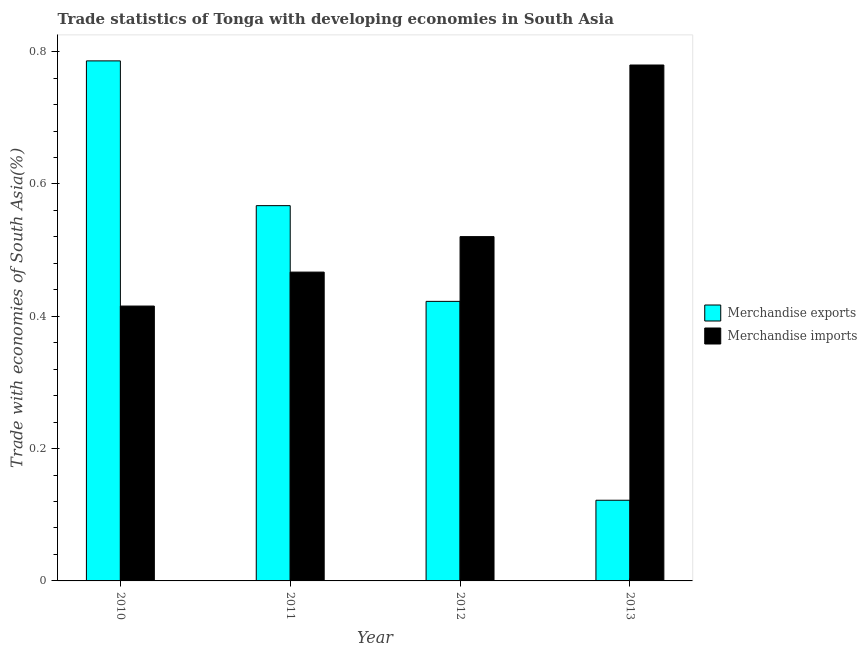How many different coloured bars are there?
Your answer should be compact. 2. Are the number of bars per tick equal to the number of legend labels?
Provide a short and direct response. Yes. How many bars are there on the 1st tick from the left?
Ensure brevity in your answer.  2. What is the label of the 2nd group of bars from the left?
Offer a very short reply. 2011. What is the merchandise imports in 2012?
Your answer should be compact. 0.52. Across all years, what is the maximum merchandise exports?
Your answer should be compact. 0.79. Across all years, what is the minimum merchandise exports?
Provide a succinct answer. 0.12. In which year was the merchandise exports minimum?
Make the answer very short. 2013. What is the total merchandise exports in the graph?
Make the answer very short. 1.9. What is the difference between the merchandise imports in 2011 and that in 2012?
Give a very brief answer. -0.05. What is the difference between the merchandise exports in 2011 and the merchandise imports in 2010?
Provide a short and direct response. -0.22. What is the average merchandise imports per year?
Your answer should be compact. 0.55. What is the ratio of the merchandise imports in 2010 to that in 2013?
Offer a very short reply. 0.53. Is the merchandise exports in 2012 less than that in 2013?
Give a very brief answer. No. Is the difference between the merchandise exports in 2011 and 2012 greater than the difference between the merchandise imports in 2011 and 2012?
Provide a short and direct response. No. What is the difference between the highest and the second highest merchandise imports?
Make the answer very short. 0.26. What is the difference between the highest and the lowest merchandise imports?
Give a very brief answer. 0.36. In how many years, is the merchandise exports greater than the average merchandise exports taken over all years?
Provide a succinct answer. 2. Is the sum of the merchandise exports in 2010 and 2012 greater than the maximum merchandise imports across all years?
Give a very brief answer. Yes. What does the 1st bar from the left in 2013 represents?
Keep it short and to the point. Merchandise exports. What does the 2nd bar from the right in 2012 represents?
Make the answer very short. Merchandise exports. How many years are there in the graph?
Your response must be concise. 4. What is the difference between two consecutive major ticks on the Y-axis?
Make the answer very short. 0.2. How are the legend labels stacked?
Your answer should be very brief. Vertical. What is the title of the graph?
Ensure brevity in your answer.  Trade statistics of Tonga with developing economies in South Asia. Does "International Visitors" appear as one of the legend labels in the graph?
Offer a terse response. No. What is the label or title of the Y-axis?
Provide a short and direct response. Trade with economies of South Asia(%). What is the Trade with economies of South Asia(%) of Merchandise exports in 2010?
Provide a short and direct response. 0.79. What is the Trade with economies of South Asia(%) in Merchandise imports in 2010?
Provide a short and direct response. 0.42. What is the Trade with economies of South Asia(%) of Merchandise exports in 2011?
Offer a very short reply. 0.57. What is the Trade with economies of South Asia(%) in Merchandise imports in 2011?
Your answer should be very brief. 0.47. What is the Trade with economies of South Asia(%) of Merchandise exports in 2012?
Provide a succinct answer. 0.42. What is the Trade with economies of South Asia(%) of Merchandise imports in 2012?
Offer a terse response. 0.52. What is the Trade with economies of South Asia(%) in Merchandise exports in 2013?
Ensure brevity in your answer.  0.12. What is the Trade with economies of South Asia(%) of Merchandise imports in 2013?
Make the answer very short. 0.78. Across all years, what is the maximum Trade with economies of South Asia(%) in Merchandise exports?
Provide a succinct answer. 0.79. Across all years, what is the maximum Trade with economies of South Asia(%) of Merchandise imports?
Offer a very short reply. 0.78. Across all years, what is the minimum Trade with economies of South Asia(%) in Merchandise exports?
Your response must be concise. 0.12. Across all years, what is the minimum Trade with economies of South Asia(%) of Merchandise imports?
Offer a very short reply. 0.42. What is the total Trade with economies of South Asia(%) of Merchandise exports in the graph?
Your answer should be compact. 1.9. What is the total Trade with economies of South Asia(%) in Merchandise imports in the graph?
Your answer should be very brief. 2.18. What is the difference between the Trade with economies of South Asia(%) in Merchandise exports in 2010 and that in 2011?
Your response must be concise. 0.22. What is the difference between the Trade with economies of South Asia(%) of Merchandise imports in 2010 and that in 2011?
Give a very brief answer. -0.05. What is the difference between the Trade with economies of South Asia(%) in Merchandise exports in 2010 and that in 2012?
Provide a succinct answer. 0.36. What is the difference between the Trade with economies of South Asia(%) of Merchandise imports in 2010 and that in 2012?
Your answer should be very brief. -0.1. What is the difference between the Trade with economies of South Asia(%) in Merchandise exports in 2010 and that in 2013?
Your answer should be very brief. 0.66. What is the difference between the Trade with economies of South Asia(%) in Merchandise imports in 2010 and that in 2013?
Provide a succinct answer. -0.36. What is the difference between the Trade with economies of South Asia(%) of Merchandise exports in 2011 and that in 2012?
Your answer should be compact. 0.14. What is the difference between the Trade with economies of South Asia(%) of Merchandise imports in 2011 and that in 2012?
Give a very brief answer. -0.05. What is the difference between the Trade with economies of South Asia(%) in Merchandise exports in 2011 and that in 2013?
Offer a terse response. 0.45. What is the difference between the Trade with economies of South Asia(%) in Merchandise imports in 2011 and that in 2013?
Offer a very short reply. -0.31. What is the difference between the Trade with economies of South Asia(%) of Merchandise exports in 2012 and that in 2013?
Your answer should be compact. 0.3. What is the difference between the Trade with economies of South Asia(%) in Merchandise imports in 2012 and that in 2013?
Your answer should be very brief. -0.26. What is the difference between the Trade with economies of South Asia(%) in Merchandise exports in 2010 and the Trade with economies of South Asia(%) in Merchandise imports in 2011?
Keep it short and to the point. 0.32. What is the difference between the Trade with economies of South Asia(%) in Merchandise exports in 2010 and the Trade with economies of South Asia(%) in Merchandise imports in 2012?
Provide a succinct answer. 0.27. What is the difference between the Trade with economies of South Asia(%) of Merchandise exports in 2010 and the Trade with economies of South Asia(%) of Merchandise imports in 2013?
Your answer should be very brief. 0.01. What is the difference between the Trade with economies of South Asia(%) of Merchandise exports in 2011 and the Trade with economies of South Asia(%) of Merchandise imports in 2012?
Ensure brevity in your answer.  0.05. What is the difference between the Trade with economies of South Asia(%) in Merchandise exports in 2011 and the Trade with economies of South Asia(%) in Merchandise imports in 2013?
Offer a very short reply. -0.21. What is the difference between the Trade with economies of South Asia(%) of Merchandise exports in 2012 and the Trade with economies of South Asia(%) of Merchandise imports in 2013?
Keep it short and to the point. -0.36. What is the average Trade with economies of South Asia(%) in Merchandise exports per year?
Keep it short and to the point. 0.47. What is the average Trade with economies of South Asia(%) in Merchandise imports per year?
Give a very brief answer. 0.55. In the year 2010, what is the difference between the Trade with economies of South Asia(%) of Merchandise exports and Trade with economies of South Asia(%) of Merchandise imports?
Your response must be concise. 0.37. In the year 2011, what is the difference between the Trade with economies of South Asia(%) in Merchandise exports and Trade with economies of South Asia(%) in Merchandise imports?
Keep it short and to the point. 0.1. In the year 2012, what is the difference between the Trade with economies of South Asia(%) in Merchandise exports and Trade with economies of South Asia(%) in Merchandise imports?
Your answer should be compact. -0.1. In the year 2013, what is the difference between the Trade with economies of South Asia(%) of Merchandise exports and Trade with economies of South Asia(%) of Merchandise imports?
Offer a terse response. -0.66. What is the ratio of the Trade with economies of South Asia(%) in Merchandise exports in 2010 to that in 2011?
Make the answer very short. 1.39. What is the ratio of the Trade with economies of South Asia(%) in Merchandise imports in 2010 to that in 2011?
Offer a terse response. 0.89. What is the ratio of the Trade with economies of South Asia(%) of Merchandise exports in 2010 to that in 2012?
Make the answer very short. 1.86. What is the ratio of the Trade with economies of South Asia(%) in Merchandise imports in 2010 to that in 2012?
Your answer should be compact. 0.8. What is the ratio of the Trade with economies of South Asia(%) in Merchandise exports in 2010 to that in 2013?
Provide a succinct answer. 6.45. What is the ratio of the Trade with economies of South Asia(%) in Merchandise imports in 2010 to that in 2013?
Provide a succinct answer. 0.53. What is the ratio of the Trade with economies of South Asia(%) of Merchandise exports in 2011 to that in 2012?
Your response must be concise. 1.34. What is the ratio of the Trade with economies of South Asia(%) of Merchandise imports in 2011 to that in 2012?
Your response must be concise. 0.9. What is the ratio of the Trade with economies of South Asia(%) of Merchandise exports in 2011 to that in 2013?
Your answer should be compact. 4.65. What is the ratio of the Trade with economies of South Asia(%) in Merchandise imports in 2011 to that in 2013?
Offer a very short reply. 0.6. What is the ratio of the Trade with economies of South Asia(%) of Merchandise exports in 2012 to that in 2013?
Your answer should be very brief. 3.46. What is the ratio of the Trade with economies of South Asia(%) in Merchandise imports in 2012 to that in 2013?
Give a very brief answer. 0.67. What is the difference between the highest and the second highest Trade with economies of South Asia(%) in Merchandise exports?
Keep it short and to the point. 0.22. What is the difference between the highest and the second highest Trade with economies of South Asia(%) of Merchandise imports?
Make the answer very short. 0.26. What is the difference between the highest and the lowest Trade with economies of South Asia(%) in Merchandise exports?
Offer a terse response. 0.66. What is the difference between the highest and the lowest Trade with economies of South Asia(%) of Merchandise imports?
Give a very brief answer. 0.36. 